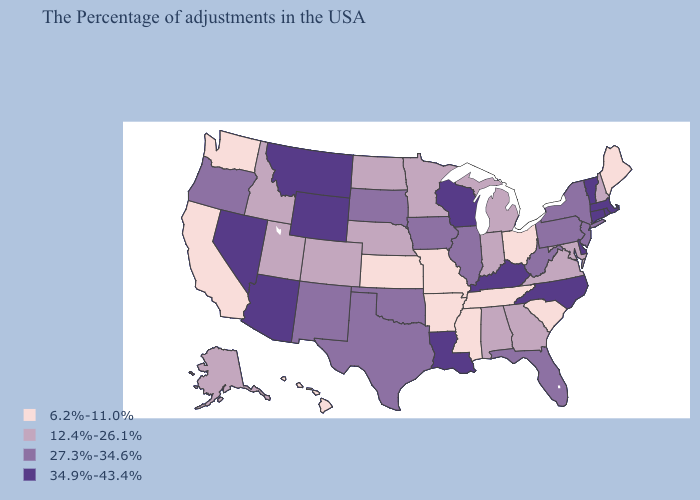Does Vermont have the highest value in the Northeast?
Give a very brief answer. Yes. Which states hav the highest value in the Northeast?
Concise answer only. Massachusetts, Rhode Island, Vermont, Connecticut. What is the value of Maine?
Answer briefly. 6.2%-11.0%. Does Virginia have a higher value than Ohio?
Be succinct. Yes. Among the states that border Maryland , does West Virginia have the lowest value?
Quick response, please. No. Does Louisiana have the highest value in the USA?
Short answer required. Yes. Does the first symbol in the legend represent the smallest category?
Keep it brief. Yes. Does Nebraska have the lowest value in the MidWest?
Quick response, please. No. Does New Mexico have a lower value than Washington?
Be succinct. No. Name the states that have a value in the range 34.9%-43.4%?
Quick response, please. Massachusetts, Rhode Island, Vermont, Connecticut, Delaware, North Carolina, Kentucky, Wisconsin, Louisiana, Wyoming, Montana, Arizona, Nevada. Does West Virginia have the highest value in the South?
Give a very brief answer. No. Does New Mexico have a lower value than Wisconsin?
Give a very brief answer. Yes. Among the states that border Indiana , which have the highest value?
Short answer required. Kentucky. What is the highest value in the MidWest ?
Quick response, please. 34.9%-43.4%. 